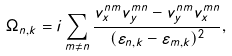Convert formula to latex. <formula><loc_0><loc_0><loc_500><loc_500>\Omega _ { n , k } = i \sum _ { m \neq n } \frac { v _ { x } ^ { n m } v _ { y } ^ { m n } - v _ { y } ^ { n m } v _ { x } ^ { m n } } { ( \varepsilon _ { n , k } - \varepsilon _ { m , k } ) ^ { 2 } } ,</formula> 